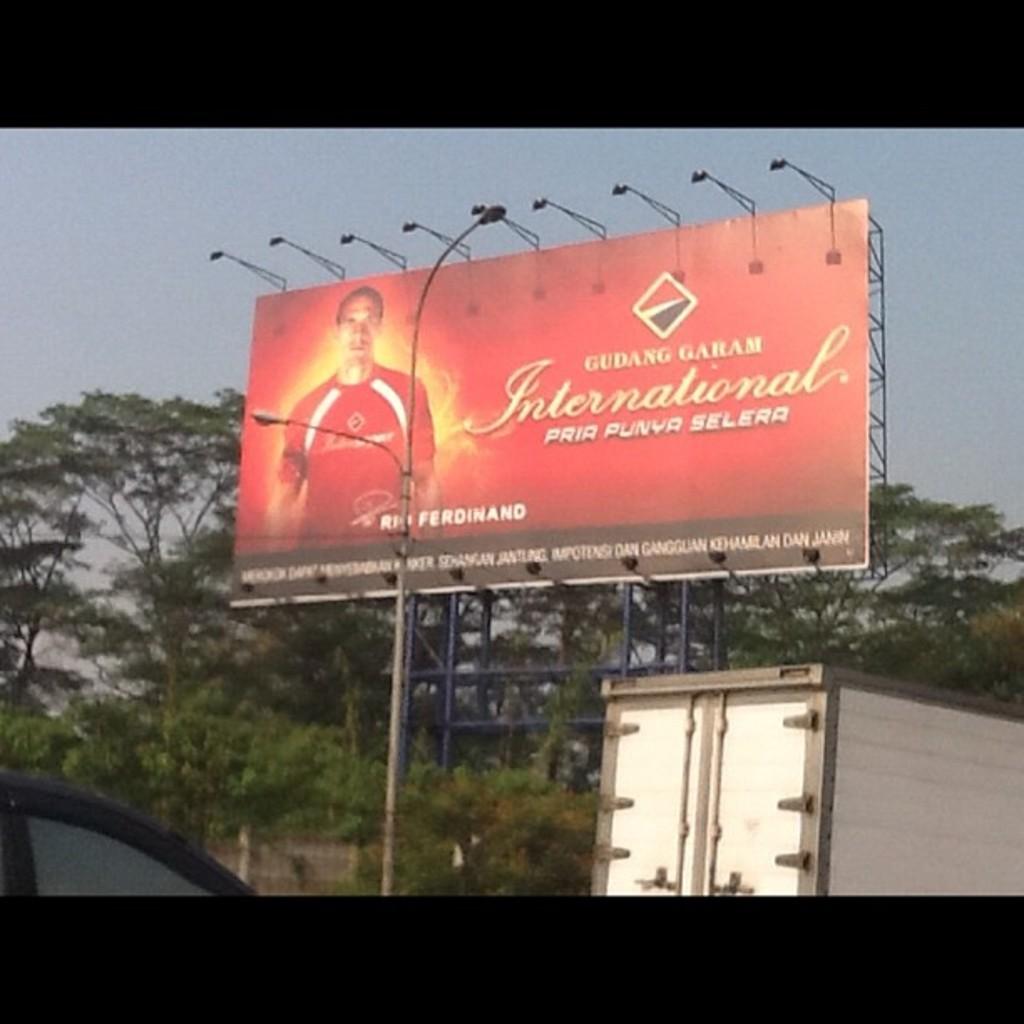What's the name of the guy on the billboard?
Your answer should be very brief. Rio ferdinand. What is the largest word on the billboard?
Your answer should be compact. International. 